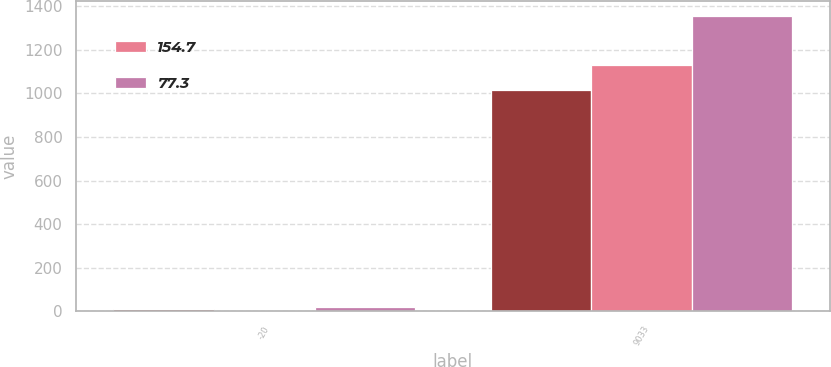Convert chart to OTSL. <chart><loc_0><loc_0><loc_500><loc_500><stacked_bar_chart><ecel><fcel>-20<fcel>9033<nl><fcel>nan<fcel>10<fcel>1016.2<nl><fcel>154.7<fcel>0<fcel>1129.2<nl><fcel>77.3<fcel>20<fcel>1355<nl></chart> 